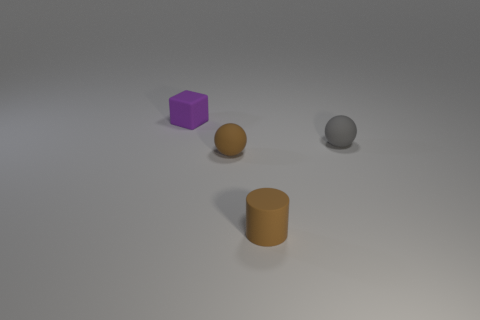Add 1 metal objects. How many objects exist? 5 Subtract all cubes. How many objects are left? 3 Add 4 cyan rubber things. How many cyan rubber things exist? 4 Subtract 0 purple balls. How many objects are left? 4 Subtract all tiny purple rubber cubes. Subtract all tiny purple rubber things. How many objects are left? 2 Add 3 brown rubber objects. How many brown rubber objects are left? 5 